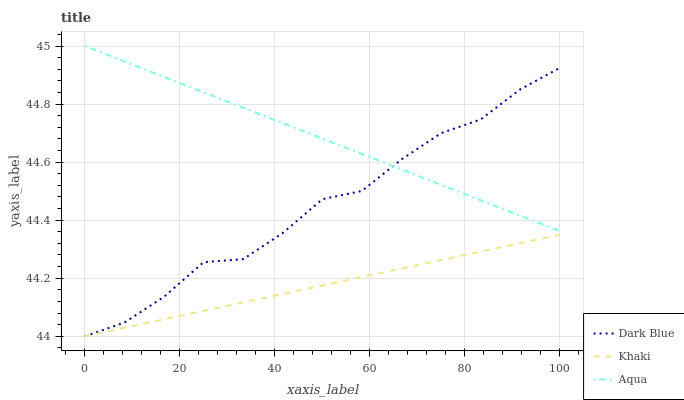Does Aqua have the minimum area under the curve?
Answer yes or no. No. Does Khaki have the maximum area under the curve?
Answer yes or no. No. Is Khaki the smoothest?
Answer yes or no. No. Is Khaki the roughest?
Answer yes or no. No. Does Aqua have the lowest value?
Answer yes or no. No. Does Khaki have the highest value?
Answer yes or no. No. Is Khaki less than Aqua?
Answer yes or no. Yes. Is Aqua greater than Khaki?
Answer yes or no. Yes. Does Khaki intersect Aqua?
Answer yes or no. No. 